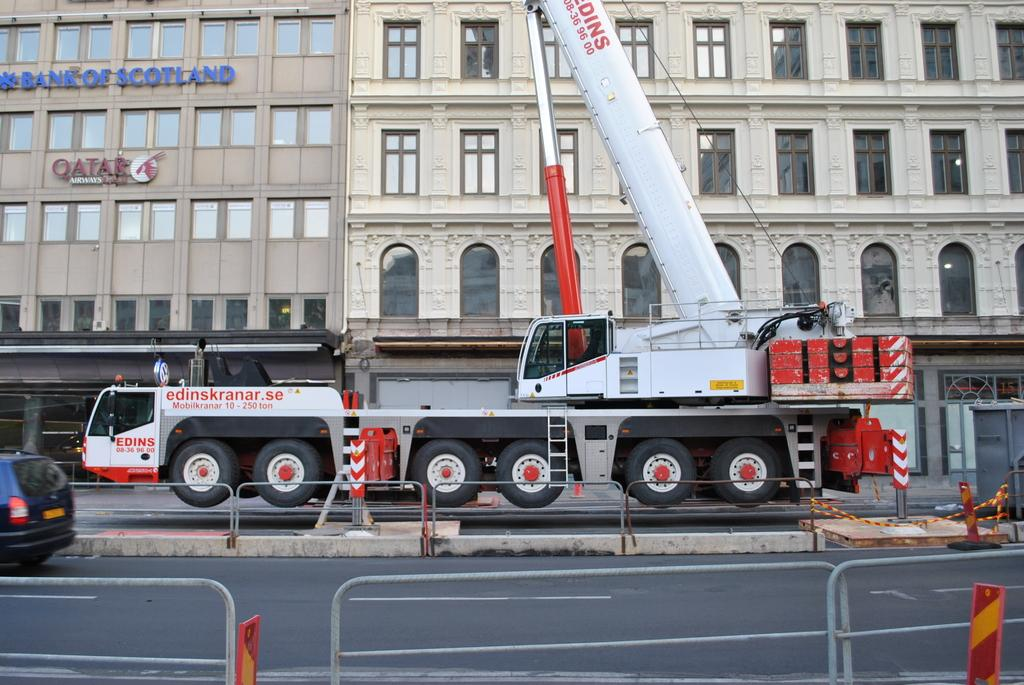What can be seen on the road in the image? There are vehicles on the road in the image. What might be used to separate or protect certain areas in the image? Barriers are visible in the image. What might be used to provide safety information in the image? Safety boards are present in the image. What can be seen in the distance in the image? There are buildings in the background of the image. Can you describe the tail of the animal in the image? There is no animal with a tail present in the image; it features vehicles, barriers, safety boards, and buildings. What type of clouds can be seen in the image? There are no clouds visible in the image. 